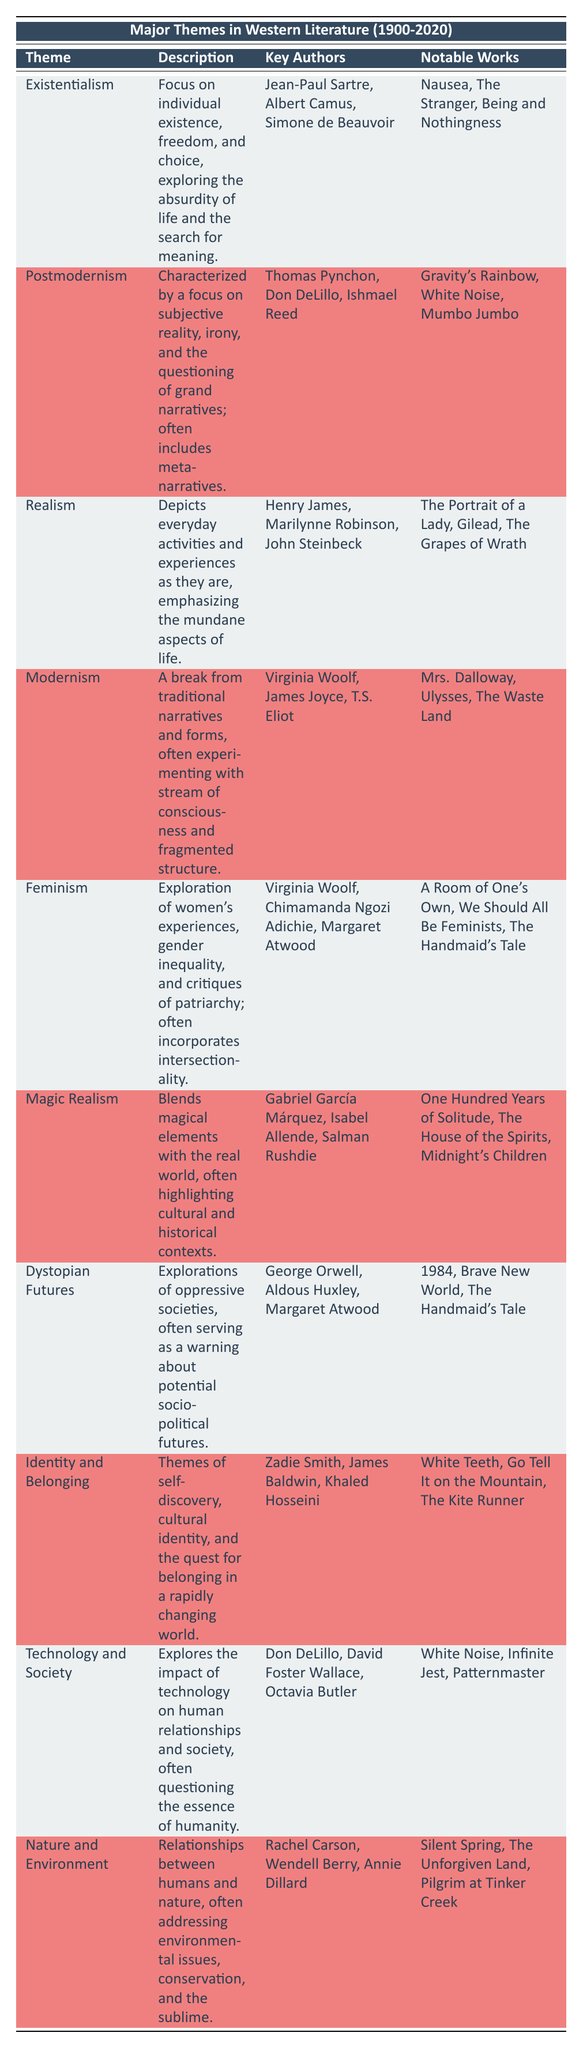What is the theme that focuses on individual existence and freedom? The theme is explicitly mentioned in the first row of the table as "Existentialism".
Answer: Existentialism Who is a key author associated with the theme of Postmodernism? The second row of the table lists "Thomas Pynchon" as one of the key authors associated with Postmodernism.
Answer: Thomas Pynchon How many notable works are associated with the theme of Dystopian Futures? In the row for Dystopian Futures, there are three notable works listed: "1984", "Brave New World", and "The Handmaid's Tale".
Answer: 3 Is "The Handmaid's Tale" a notable work in both the Dystopian Futures and Feminism themes? The table shows "The Handmaid's Tale" listed under both the Dystopian Futures and Feminism sections, indicating it is a notable work for both themes.
Answer: Yes What are the key authors of the theme that includes cultural identity and self-discovery? The row for the theme "Identity and Belonging" lists "Zadie Smith", "James Baldwin", and "Khaled Hosseini" as key authors.
Answer: Zadie Smith, James Baldwin, Khaled Hosseini Which theme has the most notable works listed, and how many are there? The themes of Dystopian Futures and Magic Realism both list three notable works, but no other theme exceeds this, confirming that these two have the most notable works.
Answer: Dystopian Futures and Magic Realism; 3 each Can you identify any commonality in the key authors of Feminism and Modernism? A detailed look reveals that "Virginia Woolf" is the only author that appears in both the Feminism and Modernism sections, indicating her dual influence in these themes.
Answer: Virginia Woolf Which theme discusses the relationship between humans and nature? The theme that discusses the relationship between humans and nature is labeled as "Nature and Environment" in the table.
Answer: Nature and Environment Count the number of themes related to technology, and list them. The table indicates one theme related to technology, which is "Technology and Society". Since this is the only entry, the count is one.
Answer: 1; Technology and Society What is the general description of the theme of Magic Realism? The description for Magic Realism is "Blends magical elements with the real world, often highlighting cultural and historical contexts."
Answer: Blends magical elements with the real world 